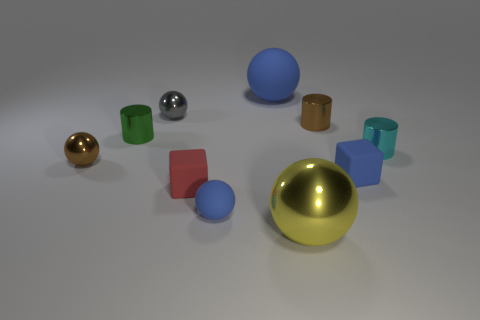What number of large balls are the same material as the tiny red cube?
Ensure brevity in your answer.  1. There is a tiny red cube; are there any cylinders left of it?
Provide a short and direct response. Yes. There is another shiny ball that is the same size as the brown sphere; what color is it?
Your answer should be very brief. Gray. How many things are tiny spheres that are on the right side of the red matte object or brown spheres?
Keep it short and to the point. 2. What is the size of the shiny sphere that is in front of the tiny green object and left of the tiny red cube?
Provide a succinct answer. Small. There is a matte cube that is the same color as the big matte thing; what is its size?
Keep it short and to the point. Small. How many other things are there of the same size as the gray sphere?
Give a very brief answer. 7. What is the color of the shiny sphere in front of the small blue thing on the left side of the block that is right of the brown cylinder?
Your answer should be compact. Yellow. There is a thing that is in front of the cyan metallic cylinder and behind the tiny blue block; what shape is it?
Your answer should be compact. Sphere. How many other objects are there of the same shape as the yellow thing?
Make the answer very short. 4. 